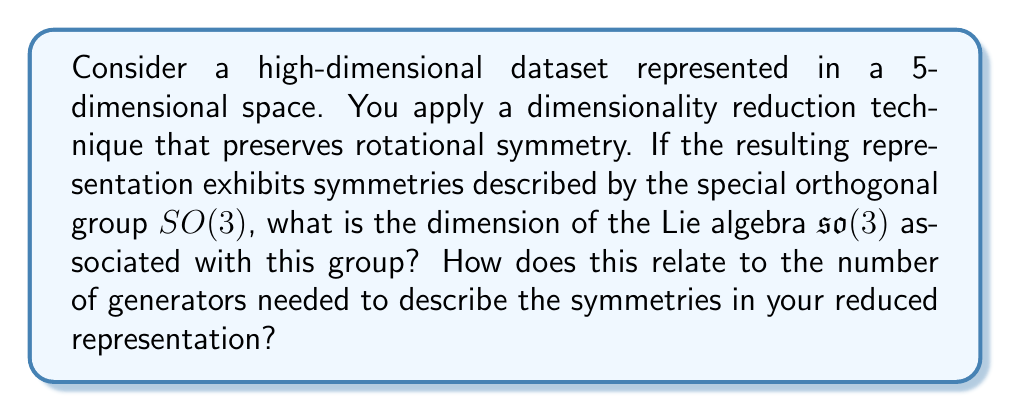Could you help me with this problem? To solve this problem, we need to follow these steps:

1) First, recall that for any Lie group $G$, its associated Lie algebra $\mathfrak{g}$ is the tangent space at the identity element of the group.

2) The special orthogonal group $SO(3)$ consists of all 3x3 orthogonal matrices with determinant 1. These matrices represent rotations in 3D space.

3) To find the dimension of $\mathfrak{so}(3)$, we need to count the number of independent parameters needed to specify an element of $SO(3)$.

4) A rotation in 3D space can be fully described by 3 parameters (e.g., Euler angles). Therefore, $SO(3)$ is a 3-dimensional manifold.

5) The dimension of the Lie algebra $\mathfrak{so}(3)$ is equal to the dimension of the Lie group $SO(3)$. Thus, $\dim(\mathfrak{so}(3)) = 3$.

6) In terms of generators, the number of generators of a Lie algebra is equal to its dimension. Therefore, we need 3 generators to describe the symmetries in the reduced representation.

7) These 3 generators correspond to infinitesimal rotations around the x, y, and z axes, and can be represented by the following matrices:

   $$J_x = \begin{pmatrix}
   0 & 0 & 0 \\
   0 & 0 & -1 \\
   0 & 1 & 0
   \end{pmatrix}, \quad
   J_y = \begin{pmatrix}
   0 & 0 & 1 \\
   0 & 0 & 0 \\
   -1 & 0 & 0
   \end{pmatrix}, \quad
   J_z = \begin{pmatrix}
   0 & -1 & 0 \\
   1 & 0 & 0 \\
   0 & 0 & 0
   \end{pmatrix}$$

8) From a data visualization perspective, this means that your reduced representation has 3 degrees of freedom for rotation, which could be important for creating interactive 3D visualizations of your high-dimensional data.
Answer: The dimension of the Lie algebra $\mathfrak{so}(3)$ is 3. This corresponds to the 3 generators needed to describe the symmetries in the reduced representation, which align with the 3 degrees of rotational freedom in 3D space. 